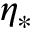Convert formula to latex. <formula><loc_0><loc_0><loc_500><loc_500>\eta _ { * }</formula> 